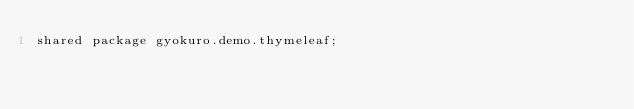Convert code to text. <code><loc_0><loc_0><loc_500><loc_500><_Ceylon_>shared package gyokuro.demo.thymeleaf;
</code> 